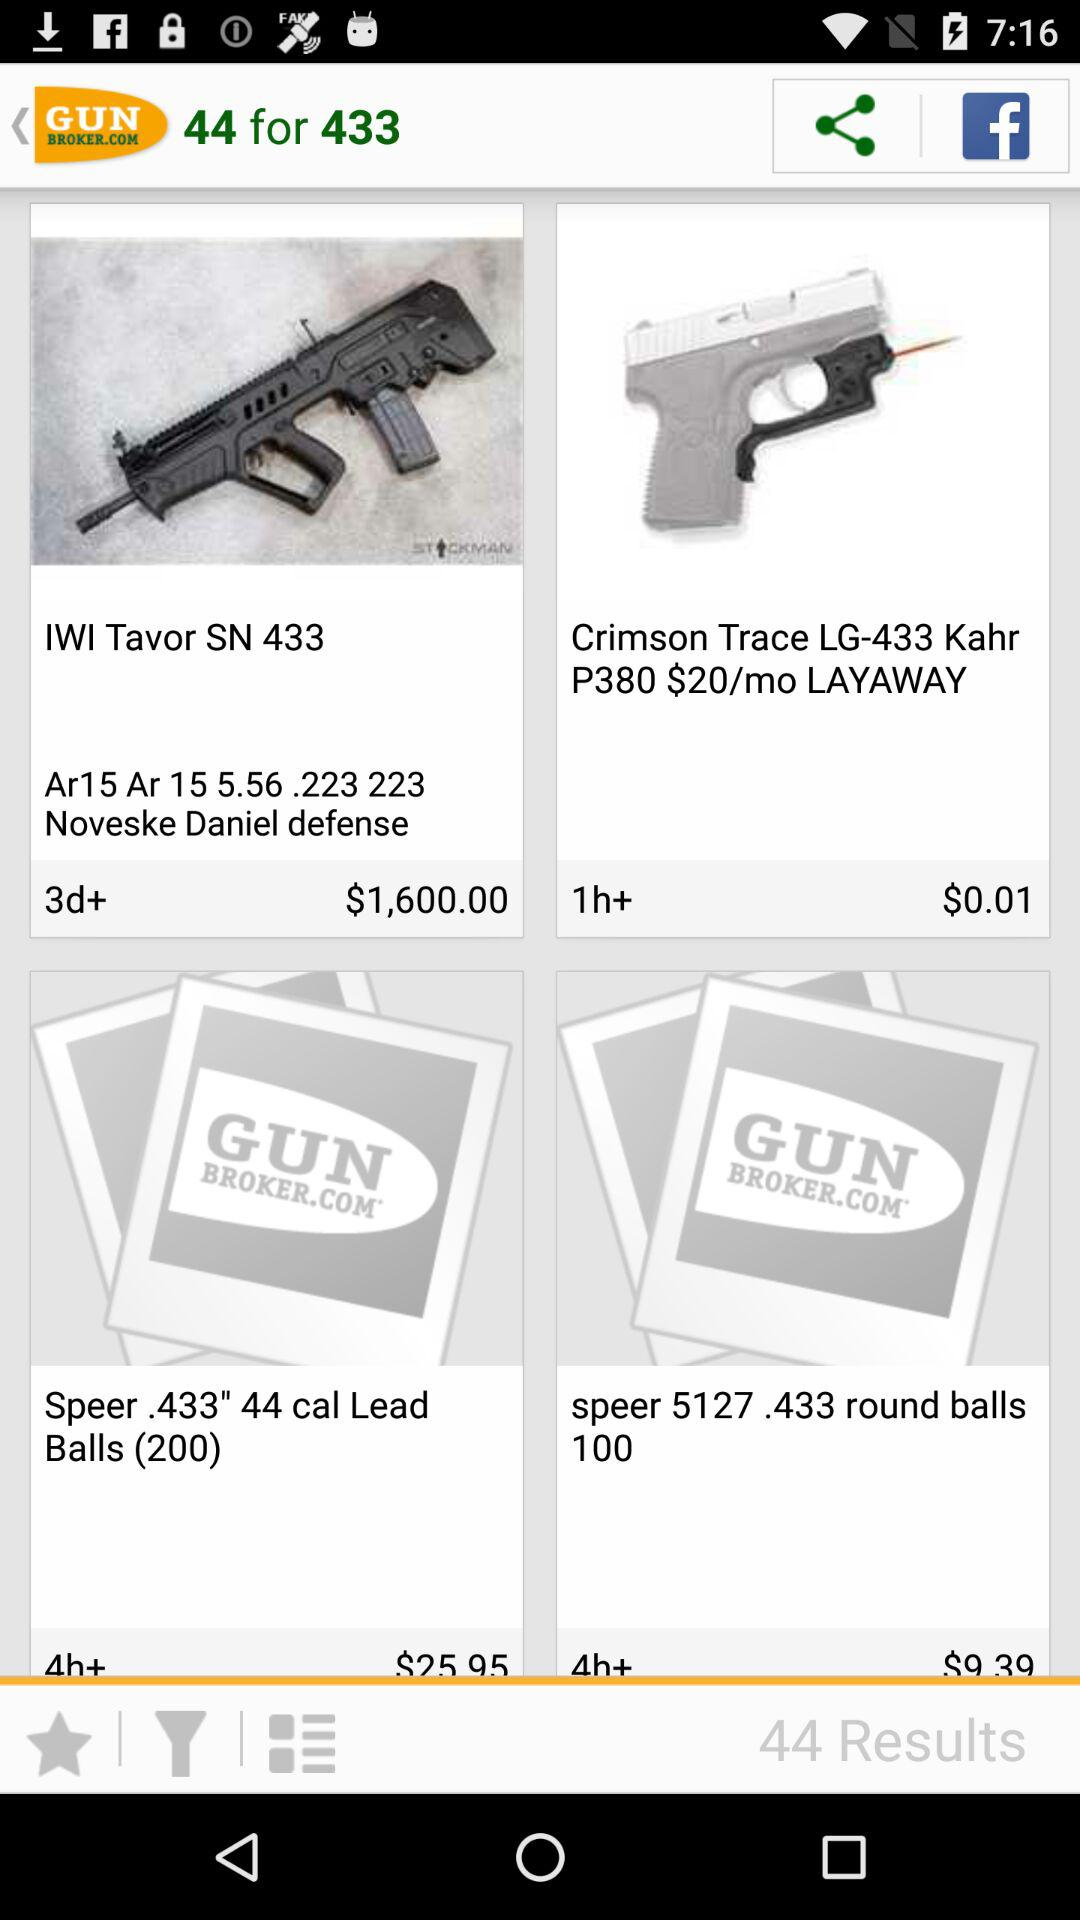How many results in total are there? There are 433 results in total. 